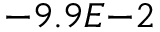<formula> <loc_0><loc_0><loc_500><loc_500>- 9 . 9 E { - 2 }</formula> 